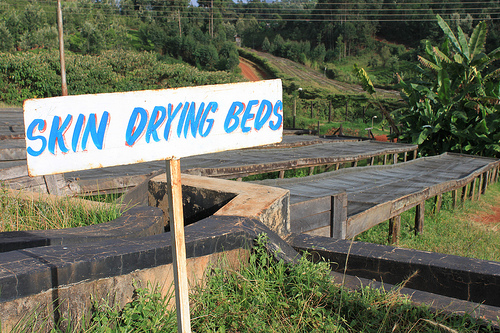<image>
Is the pole behind the wires? Yes. From this viewpoint, the pole is positioned behind the wires, with the wires partially or fully occluding the pole. 